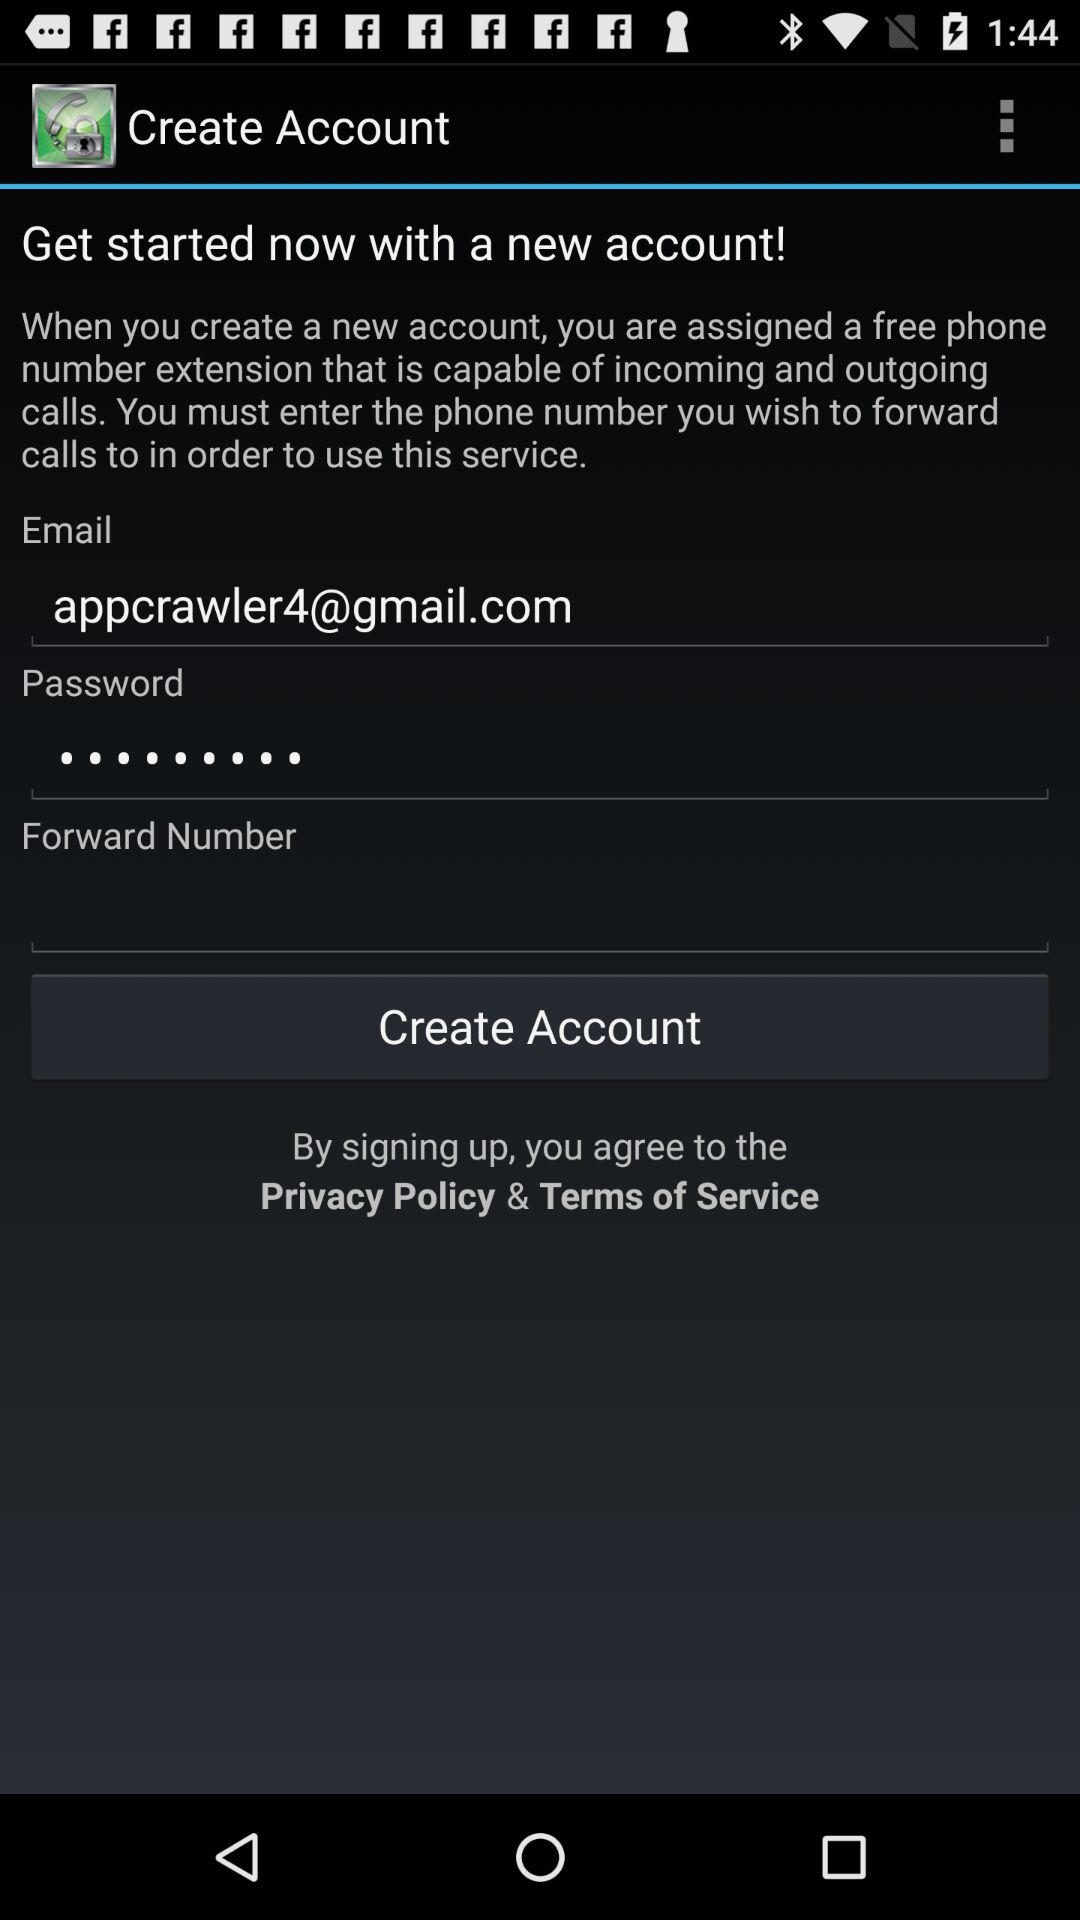What is the email address? The email address is appcrawler4@gmail.com. 